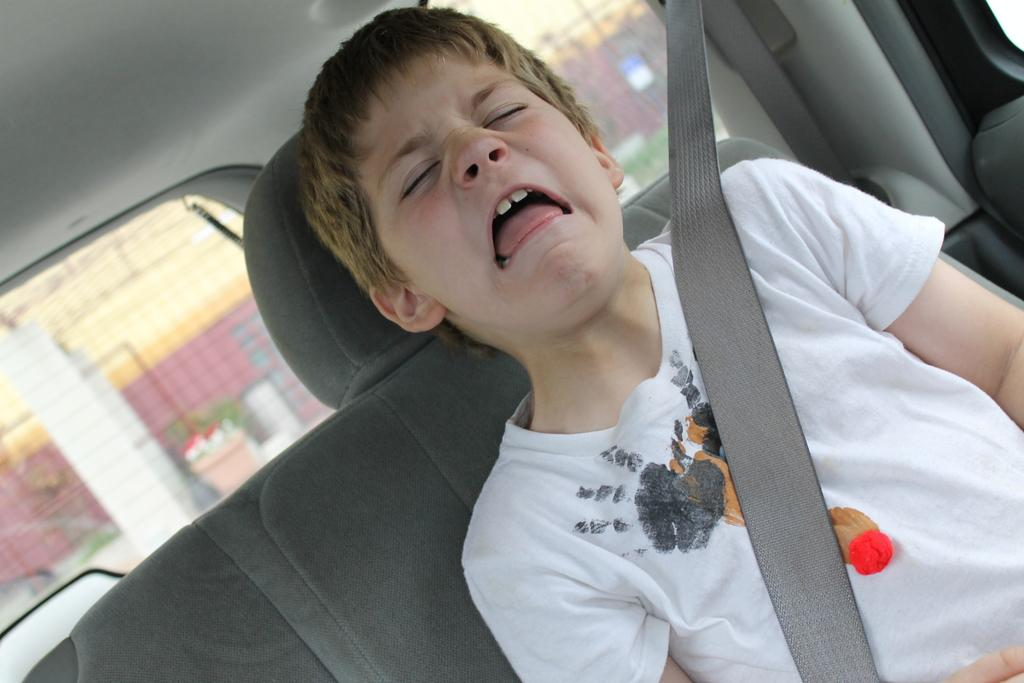What is the setting of the image? The image shows the inside view of a car. Who is present in the car? There is a boy in the car. What is the boy doing in the car? The boy is sitting. Is the boy taking any safety precautions in the car? Yes, the boy is wearing a seat belt. How is the background of the image depicted? The background is blurred. What type of cord is visible on the page in the image? There is no page or cord present in the image; it shows the inside view of a car with a boy sitting in it. 